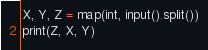Convert code to text. <code><loc_0><loc_0><loc_500><loc_500><_Python_>X, Y, Z = map(int, input().split())
print(Z, X, Y)
</code> 